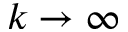Convert formula to latex. <formula><loc_0><loc_0><loc_500><loc_500>k \to \infty</formula> 